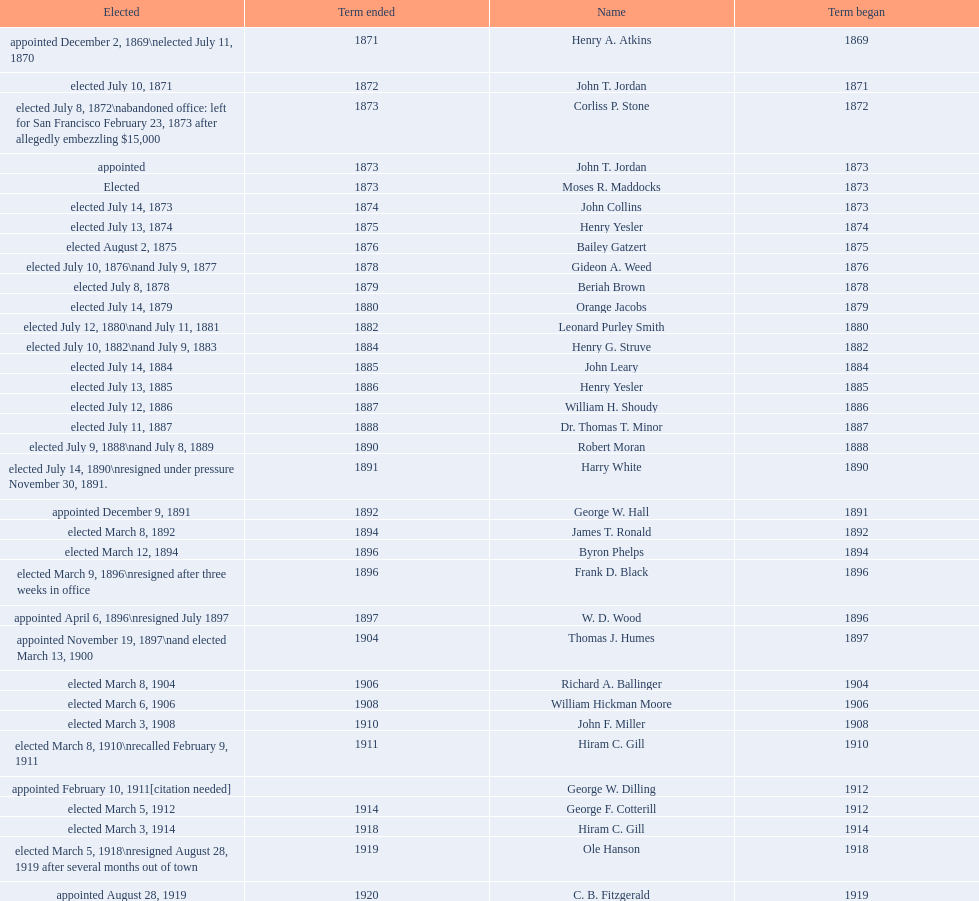Who was the first mayor in the 1900's? Richard A. Ballinger. 